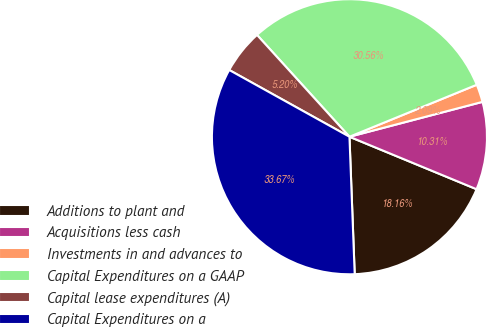Convert chart to OTSL. <chart><loc_0><loc_0><loc_500><loc_500><pie_chart><fcel>Additions to plant and<fcel>Acquisitions less cash<fcel>Investments in and advances to<fcel>Capital Expenditures on a GAAP<fcel>Capital lease expenditures (A)<fcel>Capital Expenditures on a<nl><fcel>18.16%<fcel>10.31%<fcel>2.09%<fcel>30.56%<fcel>5.2%<fcel>33.67%<nl></chart> 